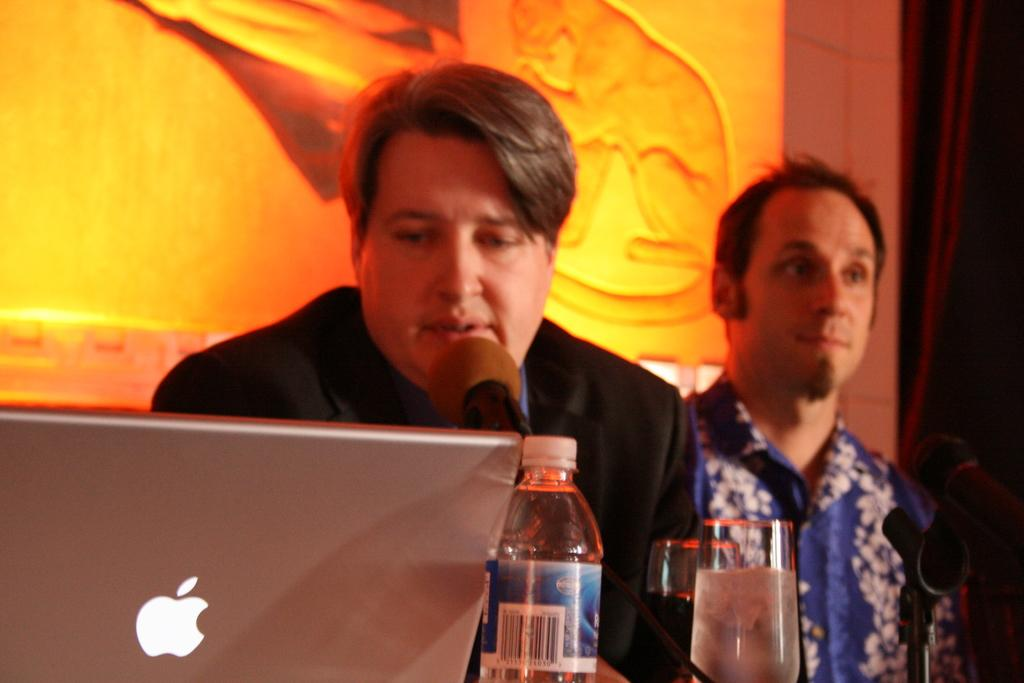How many men are in the image? There are two men in the image. What is one of the men doing? One of the men is sitting. What electronic device is in the image? There is a laptop in the image. What is the purpose of the microphone in the image? The microphone is likely used for recording or amplifying sound. What is the bottle in the image used for? The bottle could be used for holding a beverage or other liquid. What is the glass in the image used for? The glass is likely used for drinking from the bottle. Which man has the glass in front of him? The glass is in front of the man who is sitting. What can be seen in the background of the image? There is a wall and a curtain in the background of the image. Where is the toothbrush in the image? There is no toothbrush present in the image. What type of town is depicted in the image? The image does not depict a town; it features two men, electronic devices, and other objects. 